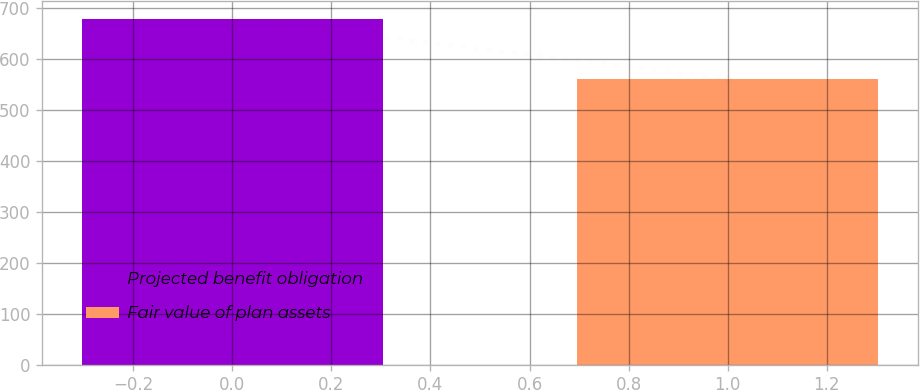Convert chart. <chart><loc_0><loc_0><loc_500><loc_500><bar_chart><fcel>Projected benefit obligation<fcel>Fair value of plan assets<nl><fcel>679<fcel>561<nl></chart> 